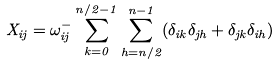<formula> <loc_0><loc_0><loc_500><loc_500>X _ { i j } = \omega ^ { - } _ { i j } \sum _ { k = 0 } ^ { n / 2 - 1 } \sum _ { h = n / 2 } ^ { n - 1 } ( \delta _ { i k } \delta _ { j h } + \delta _ { j k } \delta _ { i h } ) \,</formula> 